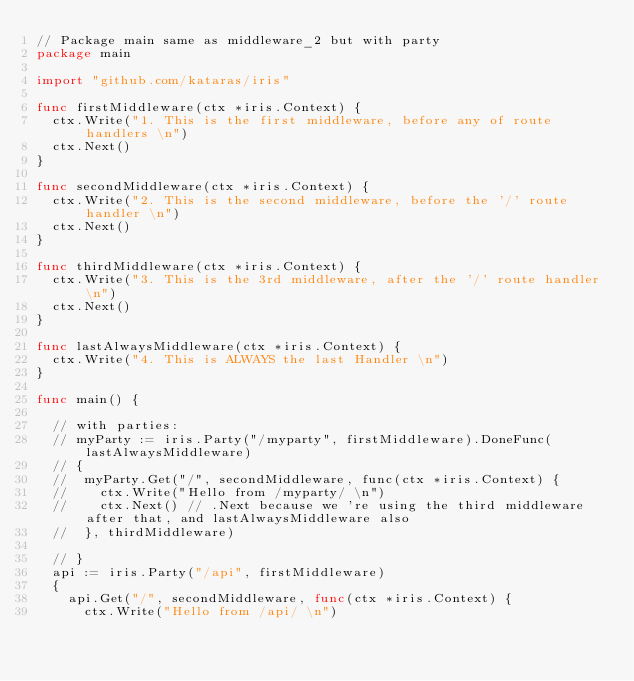Convert code to text. <code><loc_0><loc_0><loc_500><loc_500><_Go_>// Package main same as middleware_2 but with party
package main

import "github.com/kataras/iris"

func firstMiddleware(ctx *iris.Context) {
	ctx.Write("1. This is the first middleware, before any of route handlers \n")
	ctx.Next()
}

func secondMiddleware(ctx *iris.Context) {
	ctx.Write("2. This is the second middleware, before the '/' route handler \n")
	ctx.Next()
}

func thirdMiddleware(ctx *iris.Context) {
	ctx.Write("3. This is the 3rd middleware, after the '/' route handler \n")
	ctx.Next()
}

func lastAlwaysMiddleware(ctx *iris.Context) {
	ctx.Write("4. This is ALWAYS the last Handler \n")
}

func main() {

	// with parties:
	// myParty := iris.Party("/myparty", firstMiddleware).DoneFunc(lastAlwaysMiddleware)
	// {
	// 	myParty.Get("/", secondMiddleware, func(ctx *iris.Context) {
	// 		ctx.Write("Hello from /myparty/ \n")
	// 		ctx.Next() // .Next because we 're using the third middleware after that, and lastAlwaysMiddleware also
	// 	}, thirdMiddleware)

	// }
	api := iris.Party("/api", firstMiddleware)
	{
		api.Get("/", secondMiddleware, func(ctx *iris.Context) {
			ctx.Write("Hello from /api/ \n")</code> 